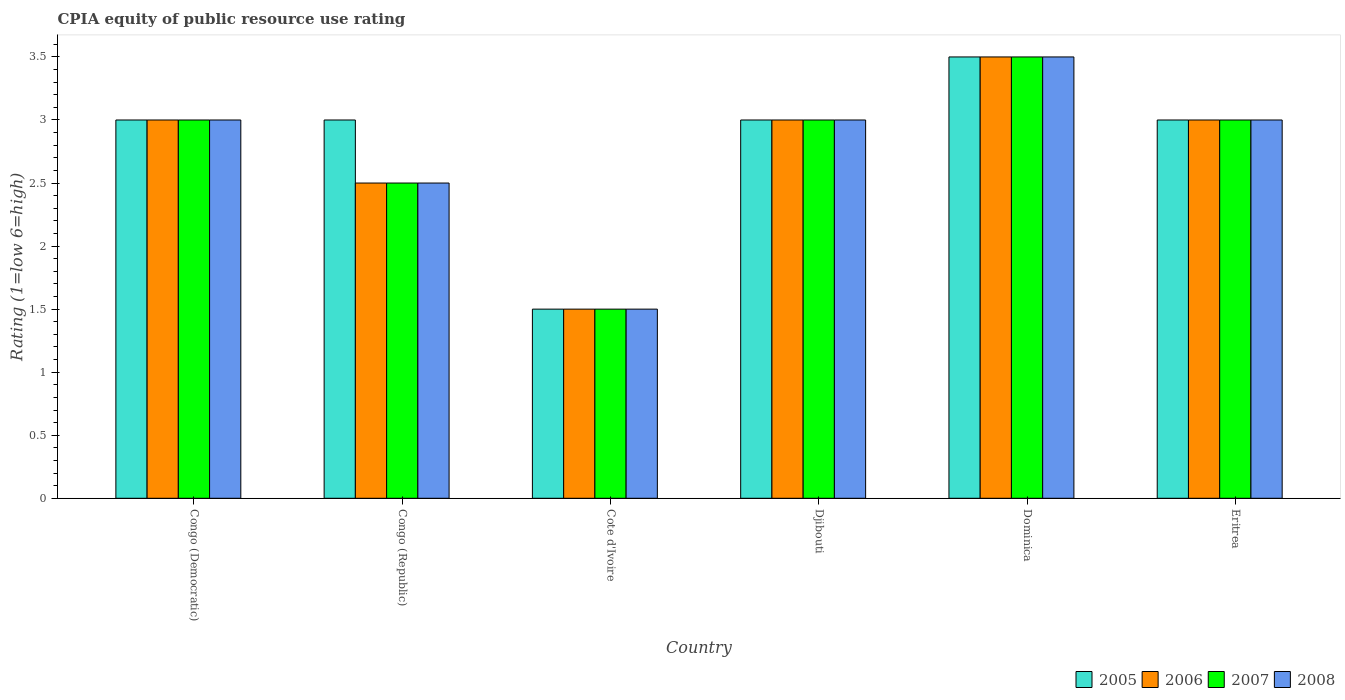How many different coloured bars are there?
Offer a terse response. 4. How many bars are there on the 5th tick from the left?
Ensure brevity in your answer.  4. What is the label of the 4th group of bars from the left?
Offer a terse response. Djibouti. In how many cases, is the number of bars for a given country not equal to the number of legend labels?
Ensure brevity in your answer.  0. In which country was the CPIA rating in 2006 maximum?
Your answer should be compact. Dominica. In which country was the CPIA rating in 2005 minimum?
Keep it short and to the point. Cote d'Ivoire. What is the total CPIA rating in 2006 in the graph?
Ensure brevity in your answer.  16.5. What is the average CPIA rating in 2007 per country?
Keep it short and to the point. 2.75. What is the difference between the CPIA rating of/in 2008 and CPIA rating of/in 2006 in Eritrea?
Offer a very short reply. 0. In how many countries, is the CPIA rating in 2008 greater than 1.9?
Your answer should be compact. 5. What is the ratio of the CPIA rating in 2008 in Congo (Republic) to that in Eritrea?
Ensure brevity in your answer.  0.83. Is the difference between the CPIA rating in 2008 in Congo (Democratic) and Djibouti greater than the difference between the CPIA rating in 2006 in Congo (Democratic) and Djibouti?
Keep it short and to the point. No. What is the difference between the highest and the second highest CPIA rating in 2007?
Your answer should be very brief. -0.5. What is the difference between the highest and the lowest CPIA rating in 2005?
Your answer should be compact. 2. In how many countries, is the CPIA rating in 2005 greater than the average CPIA rating in 2005 taken over all countries?
Offer a very short reply. 5. Is the sum of the CPIA rating in 2006 in Congo (Democratic) and Congo (Republic) greater than the maximum CPIA rating in 2008 across all countries?
Ensure brevity in your answer.  Yes. Is it the case that in every country, the sum of the CPIA rating in 2005 and CPIA rating in 2006 is greater than the sum of CPIA rating in 2007 and CPIA rating in 2008?
Provide a short and direct response. No. What does the 2nd bar from the right in Congo (Republic) represents?
Keep it short and to the point. 2007. Is it the case that in every country, the sum of the CPIA rating in 2006 and CPIA rating in 2005 is greater than the CPIA rating in 2008?
Your answer should be compact. Yes. How many countries are there in the graph?
Your response must be concise. 6. Does the graph contain any zero values?
Your answer should be compact. No. Where does the legend appear in the graph?
Your answer should be compact. Bottom right. What is the title of the graph?
Make the answer very short. CPIA equity of public resource use rating. What is the Rating (1=low 6=high) of 2007 in Congo (Democratic)?
Keep it short and to the point. 3. What is the Rating (1=low 6=high) in 2008 in Congo (Democratic)?
Provide a short and direct response. 3. What is the Rating (1=low 6=high) of 2006 in Congo (Republic)?
Ensure brevity in your answer.  2.5. What is the Rating (1=low 6=high) of 2008 in Congo (Republic)?
Provide a short and direct response. 2.5. What is the Rating (1=low 6=high) in 2008 in Cote d'Ivoire?
Your answer should be compact. 1.5. What is the Rating (1=low 6=high) of 2006 in Djibouti?
Offer a terse response. 3. What is the Rating (1=low 6=high) of 2008 in Djibouti?
Ensure brevity in your answer.  3. What is the Rating (1=low 6=high) of 2005 in Dominica?
Offer a very short reply. 3.5. What is the Rating (1=low 6=high) of 2006 in Eritrea?
Ensure brevity in your answer.  3. What is the Rating (1=low 6=high) in 2008 in Eritrea?
Make the answer very short. 3. What is the total Rating (1=low 6=high) in 2005 in the graph?
Make the answer very short. 17. What is the total Rating (1=low 6=high) of 2006 in the graph?
Provide a short and direct response. 16.5. What is the difference between the Rating (1=low 6=high) of 2005 in Congo (Democratic) and that in Congo (Republic)?
Keep it short and to the point. 0. What is the difference between the Rating (1=low 6=high) of 2006 in Congo (Democratic) and that in Congo (Republic)?
Keep it short and to the point. 0.5. What is the difference between the Rating (1=low 6=high) in 2008 in Congo (Democratic) and that in Congo (Republic)?
Provide a succinct answer. 0.5. What is the difference between the Rating (1=low 6=high) in 2007 in Congo (Democratic) and that in Cote d'Ivoire?
Provide a succinct answer. 1.5. What is the difference between the Rating (1=low 6=high) in 2007 in Congo (Democratic) and that in Djibouti?
Give a very brief answer. 0. What is the difference between the Rating (1=low 6=high) in 2008 in Congo (Democratic) and that in Djibouti?
Your answer should be very brief. 0. What is the difference between the Rating (1=low 6=high) of 2005 in Congo (Democratic) and that in Dominica?
Your answer should be very brief. -0.5. What is the difference between the Rating (1=low 6=high) of 2007 in Congo (Democratic) and that in Dominica?
Your answer should be compact. -0.5. What is the difference between the Rating (1=low 6=high) in 2008 in Congo (Democratic) and that in Dominica?
Provide a succinct answer. -0.5. What is the difference between the Rating (1=low 6=high) in 2005 in Congo (Republic) and that in Cote d'Ivoire?
Make the answer very short. 1.5. What is the difference between the Rating (1=low 6=high) of 2006 in Congo (Republic) and that in Djibouti?
Keep it short and to the point. -0.5. What is the difference between the Rating (1=low 6=high) in 2007 in Congo (Republic) and that in Djibouti?
Your response must be concise. -0.5. What is the difference between the Rating (1=low 6=high) in 2006 in Congo (Republic) and that in Dominica?
Make the answer very short. -1. What is the difference between the Rating (1=low 6=high) in 2007 in Congo (Republic) and that in Dominica?
Provide a short and direct response. -1. What is the difference between the Rating (1=low 6=high) of 2006 in Cote d'Ivoire and that in Djibouti?
Give a very brief answer. -1.5. What is the difference between the Rating (1=low 6=high) of 2008 in Cote d'Ivoire and that in Djibouti?
Your response must be concise. -1.5. What is the difference between the Rating (1=low 6=high) of 2005 in Cote d'Ivoire and that in Dominica?
Your response must be concise. -2. What is the difference between the Rating (1=low 6=high) of 2006 in Cote d'Ivoire and that in Dominica?
Make the answer very short. -2. What is the difference between the Rating (1=low 6=high) in 2005 in Djibouti and that in Eritrea?
Keep it short and to the point. 0. What is the difference between the Rating (1=low 6=high) in 2006 in Djibouti and that in Eritrea?
Your response must be concise. 0. What is the difference between the Rating (1=low 6=high) in 2007 in Djibouti and that in Eritrea?
Your answer should be very brief. 0. What is the difference between the Rating (1=low 6=high) of 2005 in Dominica and that in Eritrea?
Your answer should be compact. 0.5. What is the difference between the Rating (1=low 6=high) in 2006 in Dominica and that in Eritrea?
Give a very brief answer. 0.5. What is the difference between the Rating (1=low 6=high) of 2007 in Dominica and that in Eritrea?
Provide a succinct answer. 0.5. What is the difference between the Rating (1=low 6=high) in 2006 in Congo (Democratic) and the Rating (1=low 6=high) in 2007 in Congo (Republic)?
Your answer should be very brief. 0.5. What is the difference between the Rating (1=low 6=high) in 2006 in Congo (Democratic) and the Rating (1=low 6=high) in 2008 in Congo (Republic)?
Give a very brief answer. 0.5. What is the difference between the Rating (1=low 6=high) of 2007 in Congo (Democratic) and the Rating (1=low 6=high) of 2008 in Congo (Republic)?
Your answer should be very brief. 0.5. What is the difference between the Rating (1=low 6=high) of 2005 in Congo (Democratic) and the Rating (1=low 6=high) of 2006 in Cote d'Ivoire?
Offer a terse response. 1.5. What is the difference between the Rating (1=low 6=high) of 2005 in Congo (Democratic) and the Rating (1=low 6=high) of 2007 in Cote d'Ivoire?
Your answer should be very brief. 1.5. What is the difference between the Rating (1=low 6=high) of 2005 in Congo (Democratic) and the Rating (1=low 6=high) of 2008 in Cote d'Ivoire?
Provide a succinct answer. 1.5. What is the difference between the Rating (1=low 6=high) of 2006 in Congo (Democratic) and the Rating (1=low 6=high) of 2007 in Cote d'Ivoire?
Your response must be concise. 1.5. What is the difference between the Rating (1=low 6=high) of 2006 in Congo (Democratic) and the Rating (1=low 6=high) of 2008 in Cote d'Ivoire?
Your response must be concise. 1.5. What is the difference between the Rating (1=low 6=high) of 2005 in Congo (Democratic) and the Rating (1=low 6=high) of 2006 in Djibouti?
Provide a succinct answer. 0. What is the difference between the Rating (1=low 6=high) in 2007 in Congo (Democratic) and the Rating (1=low 6=high) in 2008 in Djibouti?
Give a very brief answer. 0. What is the difference between the Rating (1=low 6=high) of 2005 in Congo (Democratic) and the Rating (1=low 6=high) of 2007 in Dominica?
Your response must be concise. -0.5. What is the difference between the Rating (1=low 6=high) in 2005 in Congo (Democratic) and the Rating (1=low 6=high) in 2008 in Dominica?
Give a very brief answer. -0.5. What is the difference between the Rating (1=low 6=high) of 2006 in Congo (Democratic) and the Rating (1=low 6=high) of 2008 in Dominica?
Offer a terse response. -0.5. What is the difference between the Rating (1=low 6=high) of 2005 in Congo (Democratic) and the Rating (1=low 6=high) of 2007 in Eritrea?
Offer a terse response. 0. What is the difference between the Rating (1=low 6=high) in 2005 in Congo (Democratic) and the Rating (1=low 6=high) in 2008 in Eritrea?
Your answer should be very brief. 0. What is the difference between the Rating (1=low 6=high) of 2005 in Congo (Republic) and the Rating (1=low 6=high) of 2007 in Cote d'Ivoire?
Make the answer very short. 1.5. What is the difference between the Rating (1=low 6=high) in 2005 in Congo (Republic) and the Rating (1=low 6=high) in 2008 in Cote d'Ivoire?
Your answer should be compact. 1.5. What is the difference between the Rating (1=low 6=high) in 2006 in Congo (Republic) and the Rating (1=low 6=high) in 2008 in Cote d'Ivoire?
Provide a succinct answer. 1. What is the difference between the Rating (1=low 6=high) of 2007 in Congo (Republic) and the Rating (1=low 6=high) of 2008 in Cote d'Ivoire?
Ensure brevity in your answer.  1. What is the difference between the Rating (1=low 6=high) in 2005 in Congo (Republic) and the Rating (1=low 6=high) in 2006 in Djibouti?
Your answer should be very brief. 0. What is the difference between the Rating (1=low 6=high) in 2005 in Congo (Republic) and the Rating (1=low 6=high) in 2008 in Djibouti?
Ensure brevity in your answer.  0. What is the difference between the Rating (1=low 6=high) of 2006 in Congo (Republic) and the Rating (1=low 6=high) of 2007 in Djibouti?
Make the answer very short. -0.5. What is the difference between the Rating (1=low 6=high) of 2005 in Congo (Republic) and the Rating (1=low 6=high) of 2007 in Dominica?
Make the answer very short. -0.5. What is the difference between the Rating (1=low 6=high) in 2007 in Congo (Republic) and the Rating (1=low 6=high) in 2008 in Dominica?
Provide a succinct answer. -1. What is the difference between the Rating (1=low 6=high) of 2005 in Congo (Republic) and the Rating (1=low 6=high) of 2006 in Eritrea?
Your answer should be very brief. 0. What is the difference between the Rating (1=low 6=high) of 2005 in Congo (Republic) and the Rating (1=low 6=high) of 2007 in Eritrea?
Provide a short and direct response. 0. What is the difference between the Rating (1=low 6=high) in 2006 in Congo (Republic) and the Rating (1=low 6=high) in 2008 in Eritrea?
Keep it short and to the point. -0.5. What is the difference between the Rating (1=low 6=high) of 2007 in Congo (Republic) and the Rating (1=low 6=high) of 2008 in Eritrea?
Provide a short and direct response. -0.5. What is the difference between the Rating (1=low 6=high) in 2005 in Cote d'Ivoire and the Rating (1=low 6=high) in 2006 in Djibouti?
Offer a terse response. -1.5. What is the difference between the Rating (1=low 6=high) in 2006 in Cote d'Ivoire and the Rating (1=low 6=high) in 2007 in Djibouti?
Offer a very short reply. -1.5. What is the difference between the Rating (1=low 6=high) in 2006 in Cote d'Ivoire and the Rating (1=low 6=high) in 2008 in Djibouti?
Provide a succinct answer. -1.5. What is the difference between the Rating (1=low 6=high) in 2007 in Cote d'Ivoire and the Rating (1=low 6=high) in 2008 in Djibouti?
Provide a short and direct response. -1.5. What is the difference between the Rating (1=low 6=high) in 2005 in Cote d'Ivoire and the Rating (1=low 6=high) in 2006 in Dominica?
Ensure brevity in your answer.  -2. What is the difference between the Rating (1=low 6=high) of 2005 in Cote d'Ivoire and the Rating (1=low 6=high) of 2007 in Dominica?
Ensure brevity in your answer.  -2. What is the difference between the Rating (1=low 6=high) in 2005 in Cote d'Ivoire and the Rating (1=low 6=high) in 2008 in Dominica?
Your response must be concise. -2. What is the difference between the Rating (1=low 6=high) of 2006 in Cote d'Ivoire and the Rating (1=low 6=high) of 2007 in Dominica?
Your answer should be very brief. -2. What is the difference between the Rating (1=low 6=high) of 2005 in Cote d'Ivoire and the Rating (1=low 6=high) of 2006 in Eritrea?
Give a very brief answer. -1.5. What is the difference between the Rating (1=low 6=high) in 2005 in Cote d'Ivoire and the Rating (1=low 6=high) in 2007 in Eritrea?
Make the answer very short. -1.5. What is the difference between the Rating (1=low 6=high) of 2006 in Cote d'Ivoire and the Rating (1=low 6=high) of 2007 in Eritrea?
Make the answer very short. -1.5. What is the difference between the Rating (1=low 6=high) of 2006 in Cote d'Ivoire and the Rating (1=low 6=high) of 2008 in Eritrea?
Give a very brief answer. -1.5. What is the difference between the Rating (1=low 6=high) in 2005 in Djibouti and the Rating (1=low 6=high) in 2008 in Dominica?
Give a very brief answer. -0.5. What is the difference between the Rating (1=low 6=high) of 2007 in Djibouti and the Rating (1=low 6=high) of 2008 in Dominica?
Your answer should be compact. -0.5. What is the difference between the Rating (1=low 6=high) in 2005 in Djibouti and the Rating (1=low 6=high) in 2006 in Eritrea?
Make the answer very short. 0. What is the difference between the Rating (1=low 6=high) of 2005 in Djibouti and the Rating (1=low 6=high) of 2007 in Eritrea?
Make the answer very short. 0. What is the difference between the Rating (1=low 6=high) of 2006 in Djibouti and the Rating (1=low 6=high) of 2007 in Eritrea?
Provide a short and direct response. 0. What is the difference between the Rating (1=low 6=high) in 2006 in Djibouti and the Rating (1=low 6=high) in 2008 in Eritrea?
Ensure brevity in your answer.  0. What is the average Rating (1=low 6=high) in 2005 per country?
Your response must be concise. 2.83. What is the average Rating (1=low 6=high) in 2006 per country?
Offer a very short reply. 2.75. What is the average Rating (1=low 6=high) of 2007 per country?
Offer a terse response. 2.75. What is the average Rating (1=low 6=high) in 2008 per country?
Your answer should be very brief. 2.75. What is the difference between the Rating (1=low 6=high) in 2005 and Rating (1=low 6=high) in 2006 in Congo (Democratic)?
Keep it short and to the point. 0. What is the difference between the Rating (1=low 6=high) in 2005 and Rating (1=low 6=high) in 2007 in Congo (Democratic)?
Ensure brevity in your answer.  0. What is the difference between the Rating (1=low 6=high) in 2007 and Rating (1=low 6=high) in 2008 in Congo (Democratic)?
Give a very brief answer. 0. What is the difference between the Rating (1=low 6=high) in 2005 and Rating (1=low 6=high) in 2006 in Congo (Republic)?
Ensure brevity in your answer.  0.5. What is the difference between the Rating (1=low 6=high) of 2005 and Rating (1=low 6=high) of 2006 in Cote d'Ivoire?
Give a very brief answer. 0. What is the difference between the Rating (1=low 6=high) in 2005 and Rating (1=low 6=high) in 2007 in Cote d'Ivoire?
Your answer should be compact. 0. What is the difference between the Rating (1=low 6=high) of 2005 and Rating (1=low 6=high) of 2008 in Cote d'Ivoire?
Make the answer very short. 0. What is the difference between the Rating (1=low 6=high) in 2006 and Rating (1=low 6=high) in 2008 in Cote d'Ivoire?
Offer a terse response. 0. What is the difference between the Rating (1=low 6=high) of 2006 and Rating (1=low 6=high) of 2007 in Djibouti?
Provide a succinct answer. 0. What is the difference between the Rating (1=low 6=high) in 2005 and Rating (1=low 6=high) in 2006 in Dominica?
Keep it short and to the point. 0. What is the difference between the Rating (1=low 6=high) of 2005 and Rating (1=low 6=high) of 2007 in Dominica?
Your answer should be compact. 0. What is the difference between the Rating (1=low 6=high) in 2005 and Rating (1=low 6=high) in 2008 in Dominica?
Provide a short and direct response. 0. What is the difference between the Rating (1=low 6=high) of 2006 and Rating (1=low 6=high) of 2008 in Dominica?
Provide a short and direct response. 0. What is the difference between the Rating (1=low 6=high) in 2005 and Rating (1=low 6=high) in 2006 in Eritrea?
Your answer should be compact. 0. What is the difference between the Rating (1=low 6=high) in 2005 and Rating (1=low 6=high) in 2007 in Eritrea?
Ensure brevity in your answer.  0. What is the difference between the Rating (1=low 6=high) of 2006 and Rating (1=low 6=high) of 2007 in Eritrea?
Offer a very short reply. 0. What is the ratio of the Rating (1=low 6=high) in 2005 in Congo (Democratic) to that in Congo (Republic)?
Offer a terse response. 1. What is the ratio of the Rating (1=low 6=high) in 2007 in Congo (Democratic) to that in Congo (Republic)?
Keep it short and to the point. 1.2. What is the ratio of the Rating (1=low 6=high) of 2008 in Congo (Democratic) to that in Congo (Republic)?
Your answer should be compact. 1.2. What is the ratio of the Rating (1=low 6=high) in 2005 in Congo (Democratic) to that in Cote d'Ivoire?
Provide a succinct answer. 2. What is the ratio of the Rating (1=low 6=high) in 2006 in Congo (Democratic) to that in Cote d'Ivoire?
Your response must be concise. 2. What is the ratio of the Rating (1=low 6=high) of 2007 in Congo (Democratic) to that in Cote d'Ivoire?
Make the answer very short. 2. What is the ratio of the Rating (1=low 6=high) of 2005 in Congo (Democratic) to that in Djibouti?
Offer a very short reply. 1. What is the ratio of the Rating (1=low 6=high) in 2006 in Congo (Democratic) to that in Djibouti?
Your answer should be compact. 1. What is the ratio of the Rating (1=low 6=high) of 2007 in Congo (Democratic) to that in Djibouti?
Make the answer very short. 1. What is the ratio of the Rating (1=low 6=high) of 2008 in Congo (Democratic) to that in Dominica?
Ensure brevity in your answer.  0.86. What is the ratio of the Rating (1=low 6=high) of 2006 in Congo (Democratic) to that in Eritrea?
Provide a succinct answer. 1. What is the ratio of the Rating (1=low 6=high) in 2005 in Congo (Republic) to that in Cote d'Ivoire?
Offer a terse response. 2. What is the ratio of the Rating (1=low 6=high) in 2006 in Congo (Republic) to that in Cote d'Ivoire?
Offer a terse response. 1.67. What is the ratio of the Rating (1=low 6=high) in 2005 in Congo (Republic) to that in Djibouti?
Give a very brief answer. 1. What is the ratio of the Rating (1=low 6=high) in 2006 in Congo (Republic) to that in Djibouti?
Offer a terse response. 0.83. What is the ratio of the Rating (1=low 6=high) in 2007 in Congo (Republic) to that in Djibouti?
Your response must be concise. 0.83. What is the ratio of the Rating (1=low 6=high) of 2007 in Congo (Republic) to that in Dominica?
Your answer should be very brief. 0.71. What is the ratio of the Rating (1=low 6=high) of 2006 in Cote d'Ivoire to that in Djibouti?
Make the answer very short. 0.5. What is the ratio of the Rating (1=low 6=high) in 2005 in Cote d'Ivoire to that in Dominica?
Ensure brevity in your answer.  0.43. What is the ratio of the Rating (1=low 6=high) of 2006 in Cote d'Ivoire to that in Dominica?
Keep it short and to the point. 0.43. What is the ratio of the Rating (1=low 6=high) in 2007 in Cote d'Ivoire to that in Dominica?
Provide a short and direct response. 0.43. What is the ratio of the Rating (1=low 6=high) of 2008 in Cote d'Ivoire to that in Dominica?
Provide a short and direct response. 0.43. What is the ratio of the Rating (1=low 6=high) in 2005 in Cote d'Ivoire to that in Eritrea?
Provide a short and direct response. 0.5. What is the ratio of the Rating (1=low 6=high) in 2007 in Cote d'Ivoire to that in Eritrea?
Your answer should be compact. 0.5. What is the ratio of the Rating (1=low 6=high) in 2005 in Djibouti to that in Dominica?
Ensure brevity in your answer.  0.86. What is the ratio of the Rating (1=low 6=high) in 2008 in Djibouti to that in Dominica?
Offer a very short reply. 0.86. What is the ratio of the Rating (1=low 6=high) of 2005 in Djibouti to that in Eritrea?
Your response must be concise. 1. What is the ratio of the Rating (1=low 6=high) of 2006 in Djibouti to that in Eritrea?
Provide a succinct answer. 1. What is the ratio of the Rating (1=low 6=high) of 2006 in Dominica to that in Eritrea?
Ensure brevity in your answer.  1.17. What is the ratio of the Rating (1=low 6=high) of 2008 in Dominica to that in Eritrea?
Offer a terse response. 1.17. What is the difference between the highest and the second highest Rating (1=low 6=high) in 2006?
Offer a terse response. 0.5. 